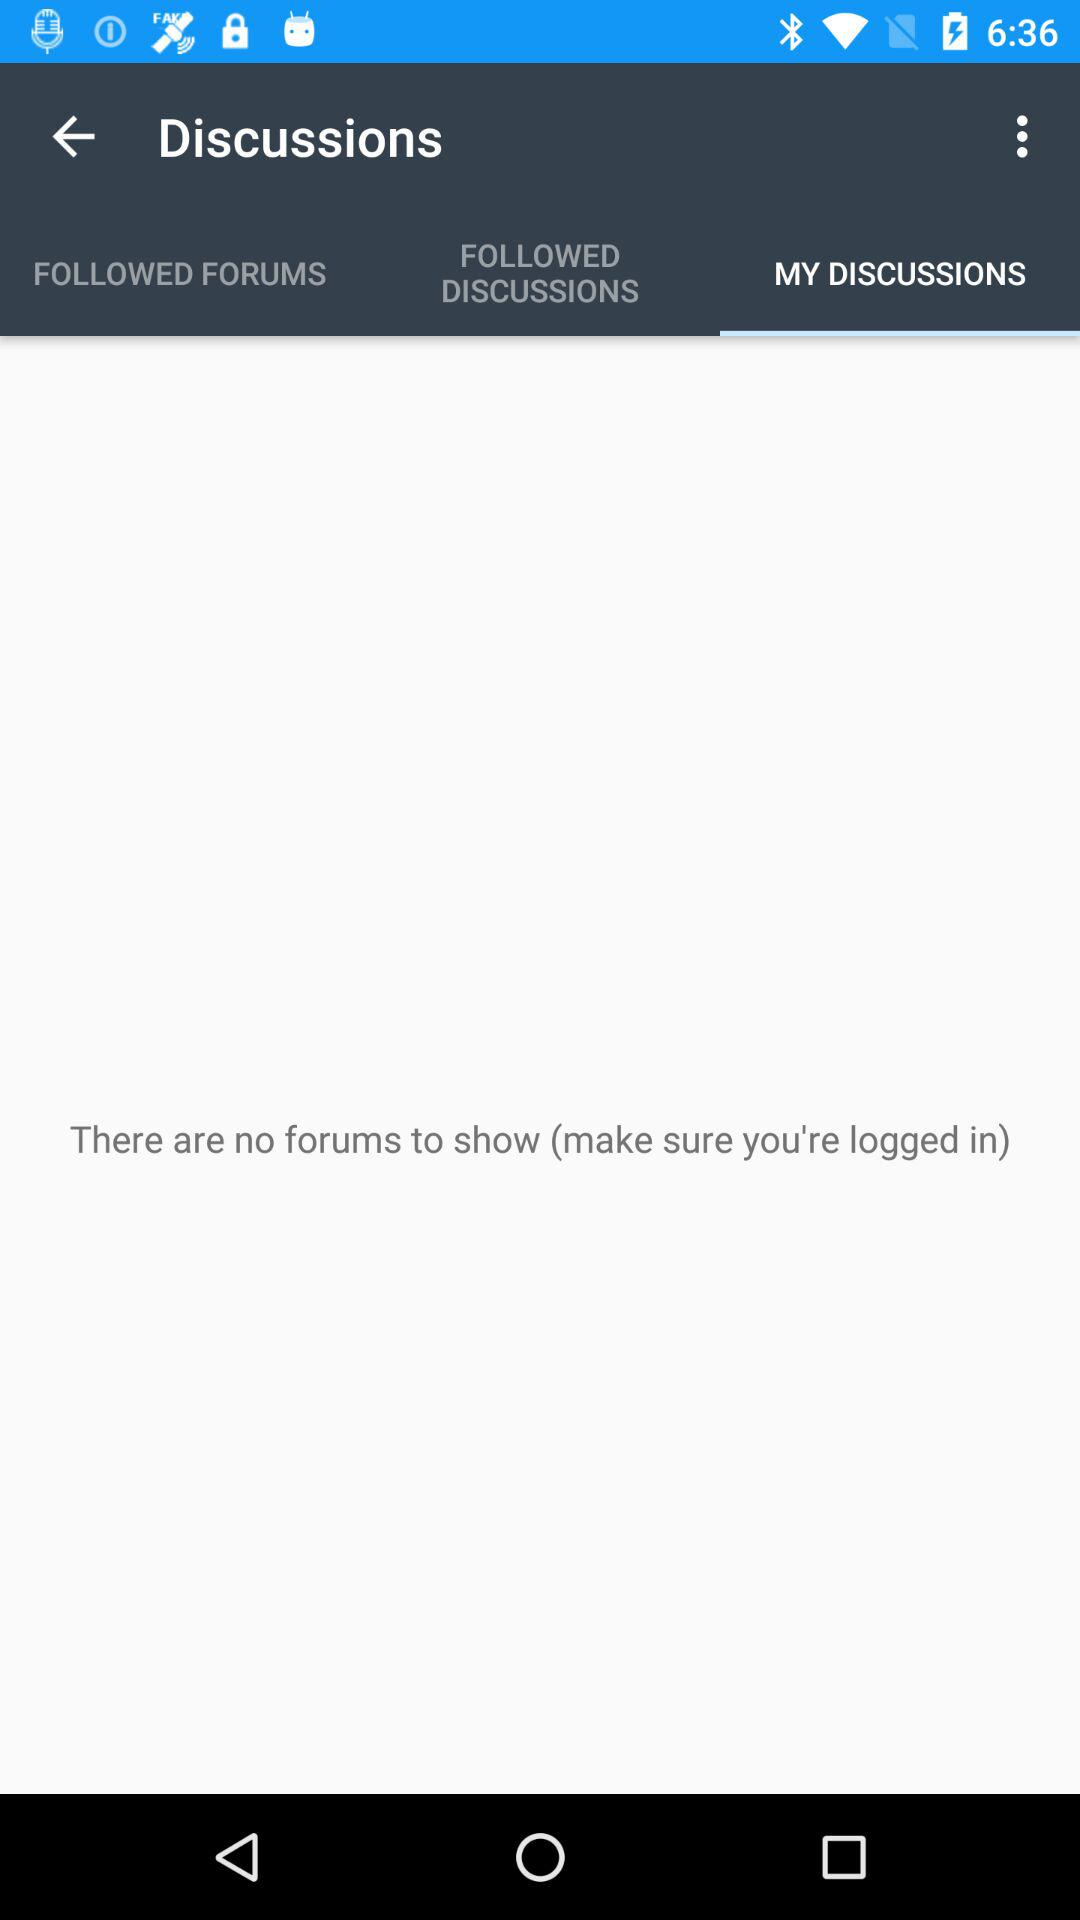Which tab is selected? The selected tab is "MY DISCUSSIONS". 